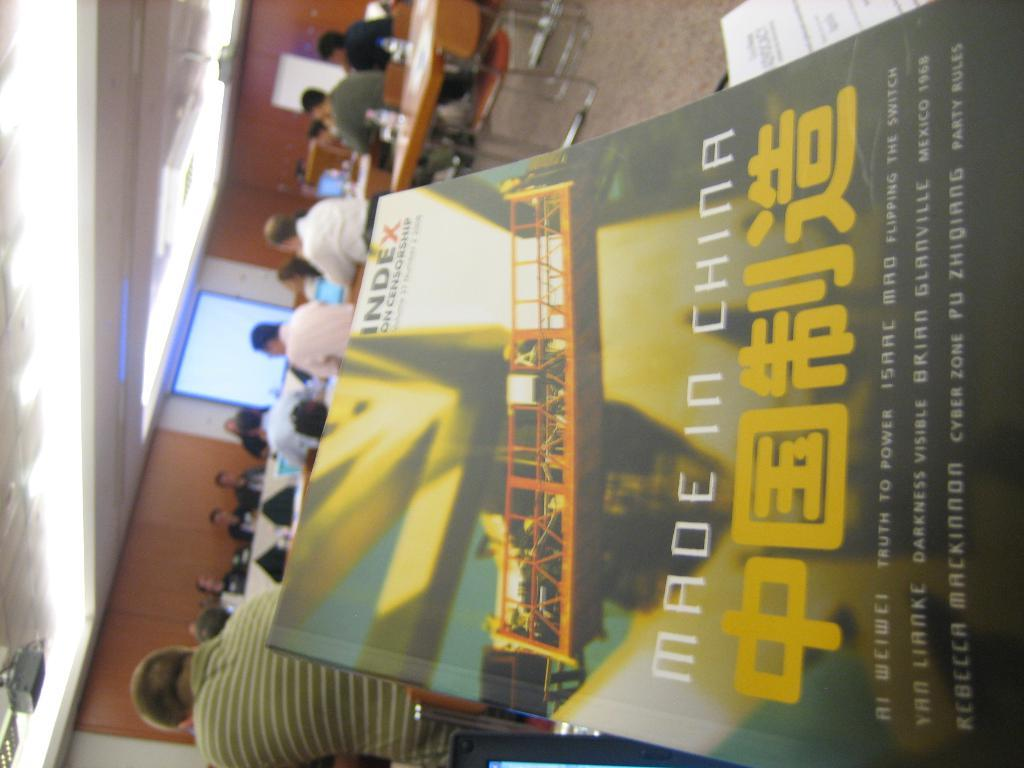<image>
Render a clear and concise summary of the photo. A book that says made in china with people sitting at desks in the background 